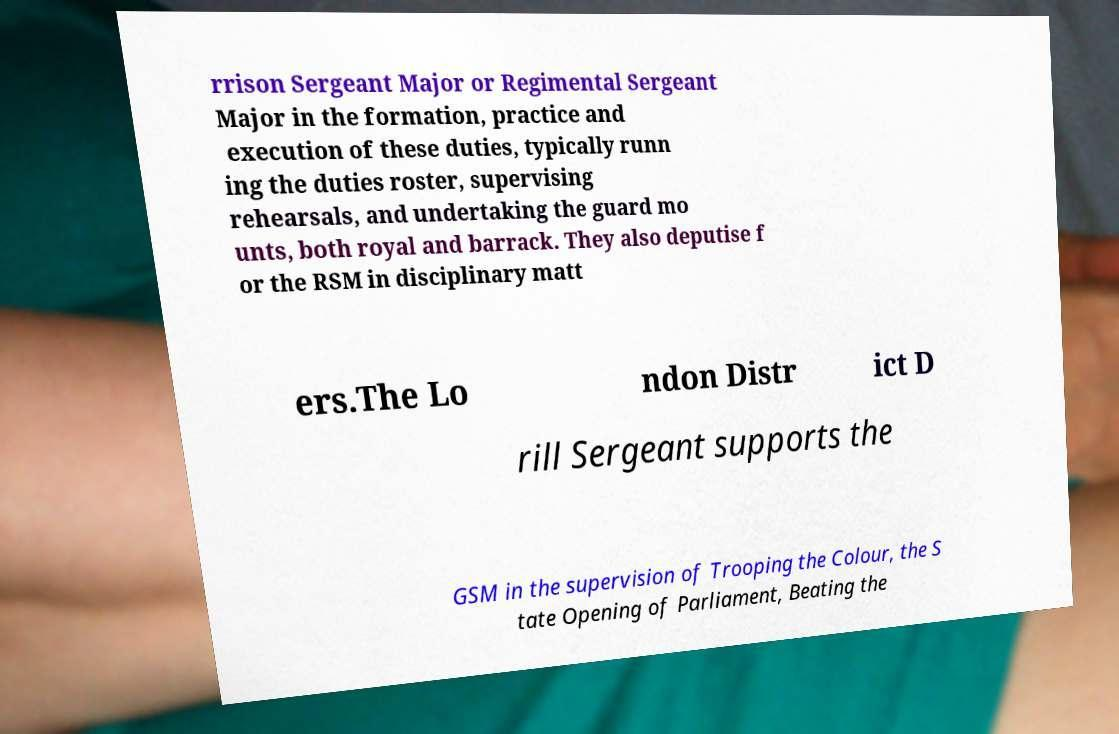For documentation purposes, I need the text within this image transcribed. Could you provide that? rrison Sergeant Major or Regimental Sergeant Major in the formation, practice and execution of these duties, typically runn ing the duties roster, supervising rehearsals, and undertaking the guard mo unts, both royal and barrack. They also deputise f or the RSM in disciplinary matt ers.The Lo ndon Distr ict D rill Sergeant supports the GSM in the supervision of Trooping the Colour, the S tate Opening of Parliament, Beating the 